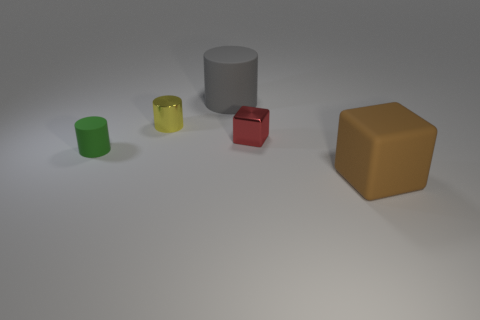What material is the block in front of the small rubber thing?
Ensure brevity in your answer.  Rubber. How big is the rubber object that is behind the tiny red shiny thing?
Offer a terse response. Large. Does the shiny cylinder behind the brown rubber block have the same size as the tiny green matte cylinder?
Offer a very short reply. Yes. Is there anything else that is the same color as the tiny shiny cylinder?
Provide a succinct answer. No. What is the shape of the small red thing?
Ensure brevity in your answer.  Cube. What number of things are both in front of the big gray matte cylinder and behind the tiny metallic cube?
Your answer should be very brief. 1. Is the large block the same color as the metallic block?
Provide a succinct answer. No. What material is the tiny yellow thing that is the same shape as the big gray matte object?
Keep it short and to the point. Metal. Are there any other things that have the same material as the small block?
Your answer should be compact. Yes. Is the number of tiny green cylinders behind the red cube the same as the number of matte cubes that are to the left of the big brown rubber thing?
Keep it short and to the point. Yes. 